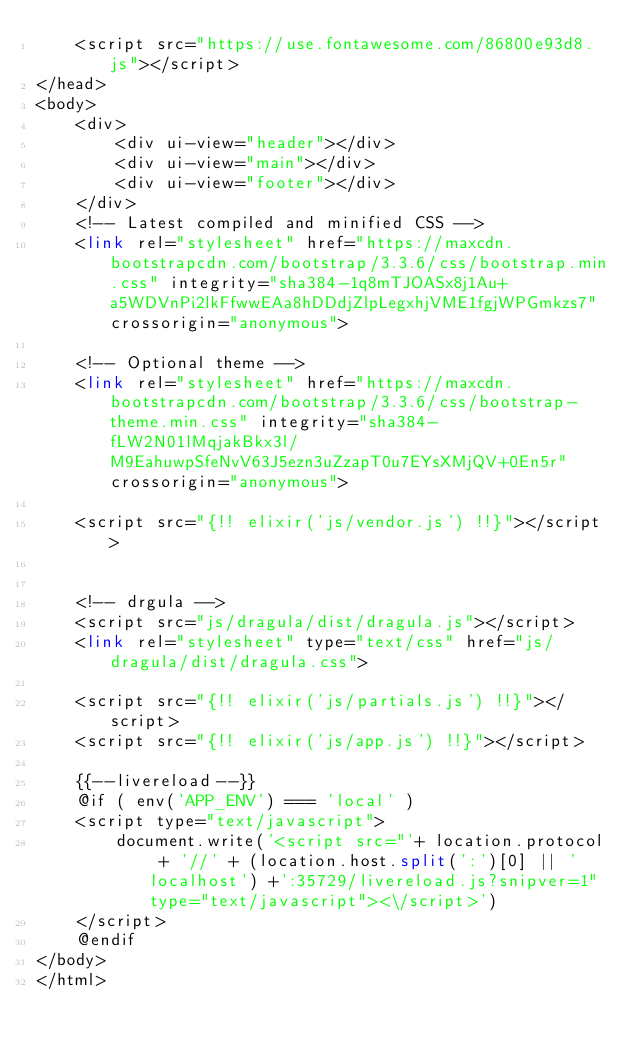Convert code to text. <code><loc_0><loc_0><loc_500><loc_500><_PHP_>    <script src="https://use.fontawesome.com/86800e93d8.js"></script>
</head>
<body>
    <div>
        <div ui-view="header"></div>
        <div ui-view="main"></div>
        <div ui-view="footer"></div>
    </div>
    <!-- Latest compiled and minified CSS -->
    <link rel="stylesheet" href="https://maxcdn.bootstrapcdn.com/bootstrap/3.3.6/css/bootstrap.min.css" integrity="sha384-1q8mTJOASx8j1Au+a5WDVnPi2lkFfwwEAa8hDDdjZlpLegxhjVME1fgjWPGmkzs7" crossorigin="anonymous">

    <!-- Optional theme -->
    <link rel="stylesheet" href="https://maxcdn.bootstrapcdn.com/bootstrap/3.3.6/css/bootstrap-theme.min.css" integrity="sha384-fLW2N01lMqjakBkx3l/M9EahuwpSfeNvV63J5ezn3uZzapT0u7EYsXMjQV+0En5r" crossorigin="anonymous">

    <script src="{!! elixir('js/vendor.js') !!}"></script>
    

    <!-- drgula -->
    <script src="js/dragula/dist/dragula.js"></script>
    <link rel="stylesheet" type="text/css" href="js/dragula/dist/dragula.css">

    <script src="{!! elixir('js/partials.js') !!}"></script>
    <script src="{!! elixir('js/app.js') !!}"></script>

    {{--livereload--}}
    @if ( env('APP_ENV') === 'local' )
    <script type="text/javascript">
        document.write('<script src="'+ location.protocol + '//' + (location.host.split(':')[0] || 'localhost') +':35729/livereload.js?snipver=1" type="text/javascript"><\/script>')
    </script>
    @endif
</body>
</html>
</code> 